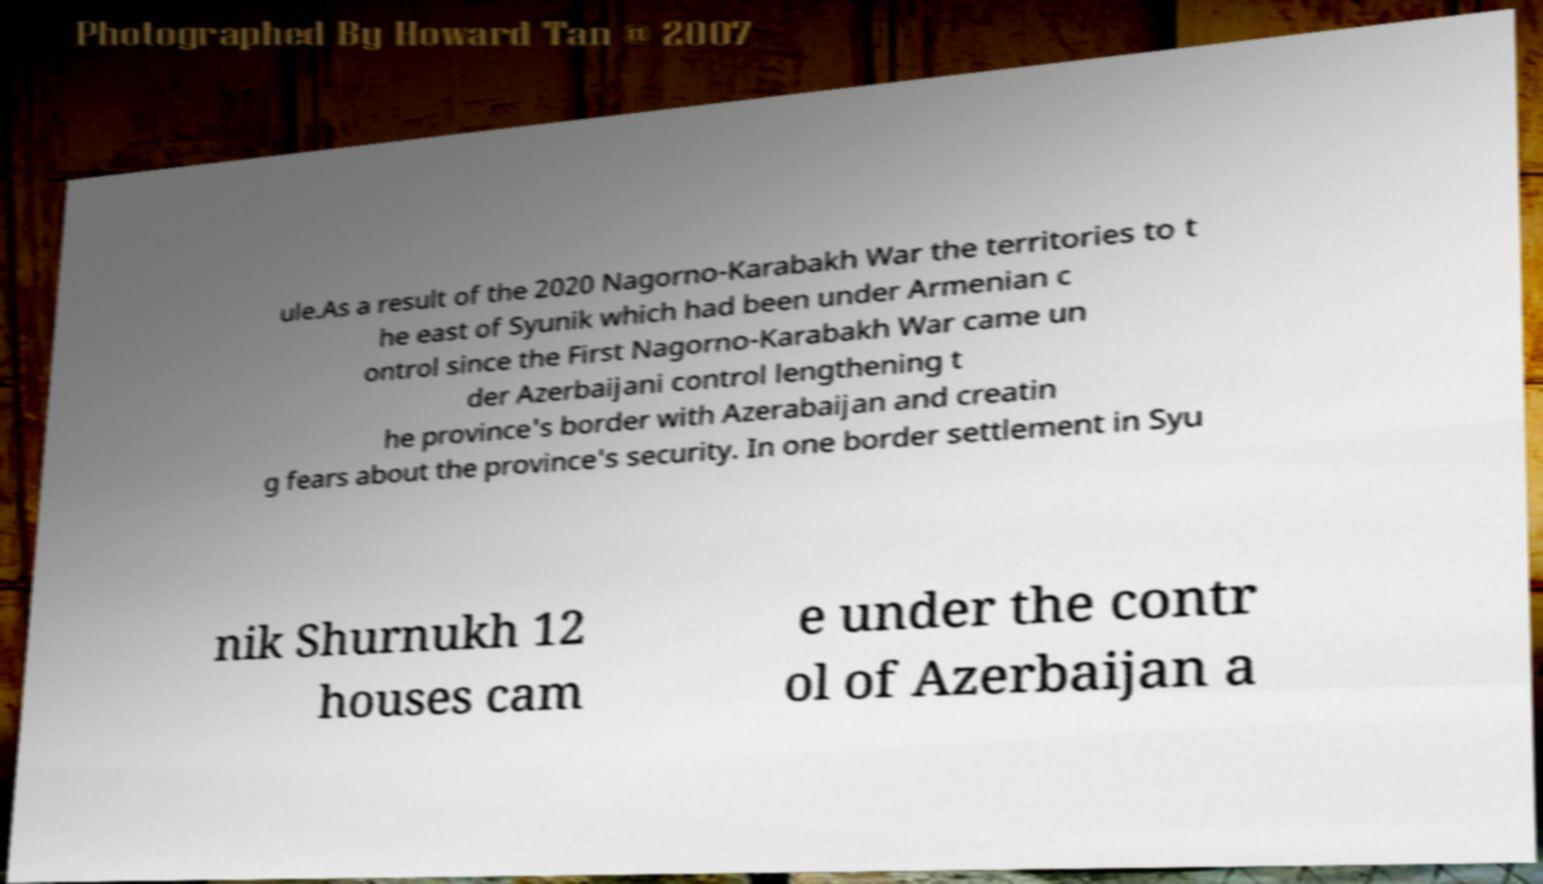There's text embedded in this image that I need extracted. Can you transcribe it verbatim? ule.As a result of the 2020 Nagorno-Karabakh War the territories to t he east of Syunik which had been under Armenian c ontrol since the First Nagorno-Karabakh War came un der Azerbaijani control lengthening t he province's border with Azerabaijan and creatin g fears about the province's security. In one border settlement in Syu nik Shurnukh 12 houses cam e under the contr ol of Azerbaijan a 